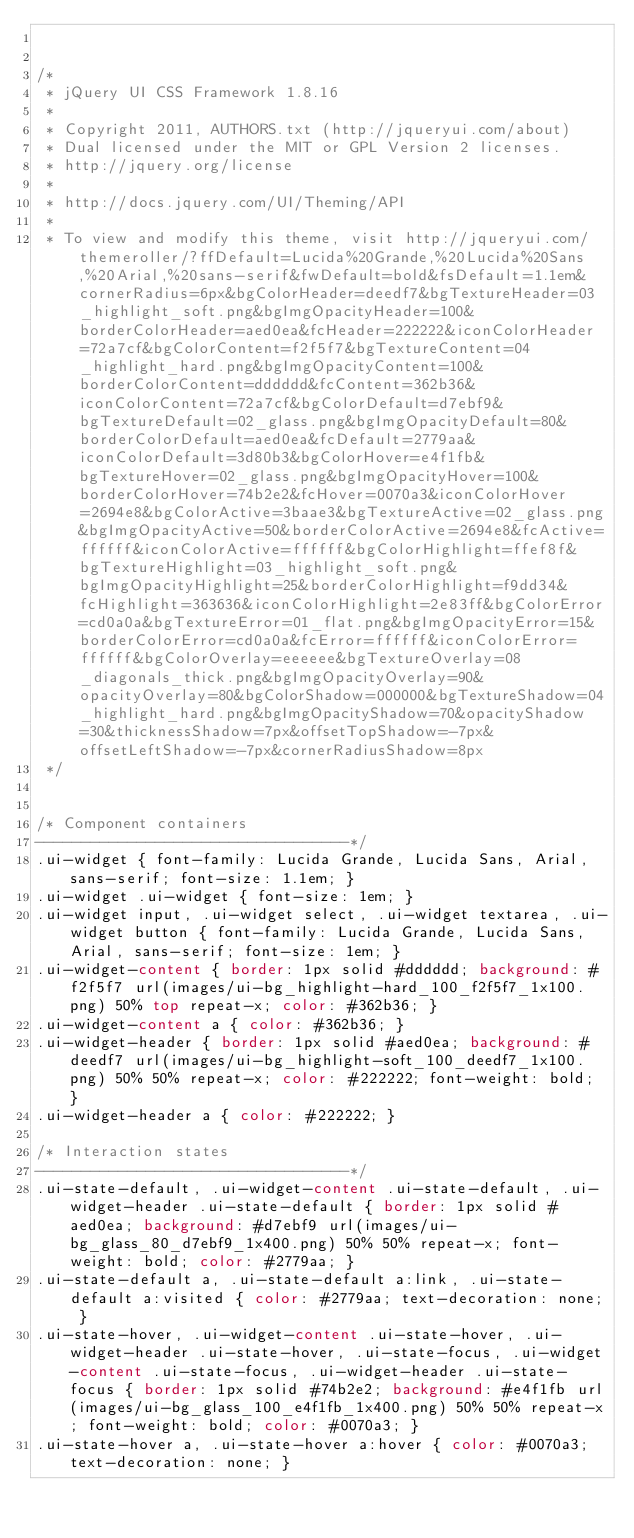Convert code to text. <code><loc_0><loc_0><loc_500><loc_500><_CSS_>

/*
 * jQuery UI CSS Framework 1.8.16
 *
 * Copyright 2011, AUTHORS.txt (http://jqueryui.com/about)
 * Dual licensed under the MIT or GPL Version 2 licenses.
 * http://jquery.org/license
 *
 * http://docs.jquery.com/UI/Theming/API
 *
 * To view and modify this theme, visit http://jqueryui.com/themeroller/?ffDefault=Lucida%20Grande,%20Lucida%20Sans,%20Arial,%20sans-serif&fwDefault=bold&fsDefault=1.1em&cornerRadius=6px&bgColorHeader=deedf7&bgTextureHeader=03_highlight_soft.png&bgImgOpacityHeader=100&borderColorHeader=aed0ea&fcHeader=222222&iconColorHeader=72a7cf&bgColorContent=f2f5f7&bgTextureContent=04_highlight_hard.png&bgImgOpacityContent=100&borderColorContent=dddddd&fcContent=362b36&iconColorContent=72a7cf&bgColorDefault=d7ebf9&bgTextureDefault=02_glass.png&bgImgOpacityDefault=80&borderColorDefault=aed0ea&fcDefault=2779aa&iconColorDefault=3d80b3&bgColorHover=e4f1fb&bgTextureHover=02_glass.png&bgImgOpacityHover=100&borderColorHover=74b2e2&fcHover=0070a3&iconColorHover=2694e8&bgColorActive=3baae3&bgTextureActive=02_glass.png&bgImgOpacityActive=50&borderColorActive=2694e8&fcActive=ffffff&iconColorActive=ffffff&bgColorHighlight=ffef8f&bgTextureHighlight=03_highlight_soft.png&bgImgOpacityHighlight=25&borderColorHighlight=f9dd34&fcHighlight=363636&iconColorHighlight=2e83ff&bgColorError=cd0a0a&bgTextureError=01_flat.png&bgImgOpacityError=15&borderColorError=cd0a0a&fcError=ffffff&iconColorError=ffffff&bgColorOverlay=eeeeee&bgTextureOverlay=08_diagonals_thick.png&bgImgOpacityOverlay=90&opacityOverlay=80&bgColorShadow=000000&bgTextureShadow=04_highlight_hard.png&bgImgOpacityShadow=70&opacityShadow=30&thicknessShadow=7px&offsetTopShadow=-7px&offsetLeftShadow=-7px&cornerRadiusShadow=8px
 */


/* Component containers
----------------------------------*/
.ui-widget { font-family: Lucida Grande, Lucida Sans, Arial, sans-serif; font-size: 1.1em; }
.ui-widget .ui-widget { font-size: 1em; }
.ui-widget input, .ui-widget select, .ui-widget textarea, .ui-widget button { font-family: Lucida Grande, Lucida Sans, Arial, sans-serif; font-size: 1em; }
.ui-widget-content { border: 1px solid #dddddd; background: #f2f5f7 url(images/ui-bg_highlight-hard_100_f2f5f7_1x100.png) 50% top repeat-x; color: #362b36; }
.ui-widget-content a { color: #362b36; }
.ui-widget-header { border: 1px solid #aed0ea; background: #deedf7 url(images/ui-bg_highlight-soft_100_deedf7_1x100.png) 50% 50% repeat-x; color: #222222; font-weight: bold; }
.ui-widget-header a { color: #222222; }

/* Interaction states
----------------------------------*/
.ui-state-default, .ui-widget-content .ui-state-default, .ui-widget-header .ui-state-default { border: 1px solid #aed0ea; background: #d7ebf9 url(images/ui-bg_glass_80_d7ebf9_1x400.png) 50% 50% repeat-x; font-weight: bold; color: #2779aa; }
.ui-state-default a, .ui-state-default a:link, .ui-state-default a:visited { color: #2779aa; text-decoration: none; }
.ui-state-hover, .ui-widget-content .ui-state-hover, .ui-widget-header .ui-state-hover, .ui-state-focus, .ui-widget-content .ui-state-focus, .ui-widget-header .ui-state-focus { border: 1px solid #74b2e2; background: #e4f1fb url(images/ui-bg_glass_100_e4f1fb_1x400.png) 50% 50% repeat-x; font-weight: bold; color: #0070a3; }
.ui-state-hover a, .ui-state-hover a:hover { color: #0070a3; text-decoration: none; }</code> 